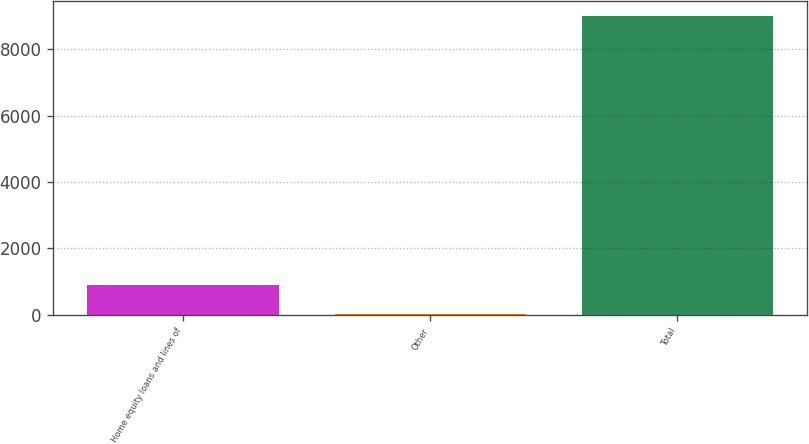<chart> <loc_0><loc_0><loc_500><loc_500><bar_chart><fcel>Home equity loans and lines of<fcel>Other<fcel>Total<nl><fcel>903.8<fcel>3<fcel>9011<nl></chart> 